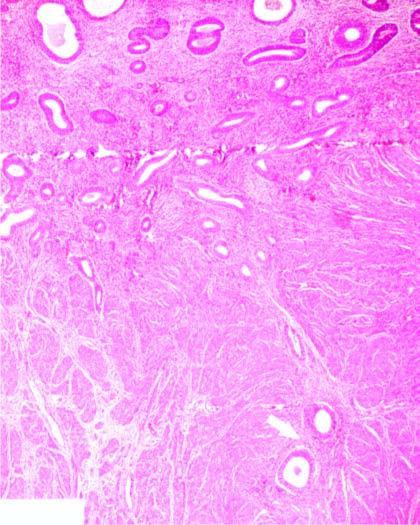what are present deep inside the myometrium?
Answer the question using a single word or phrase. Endometrial glands 